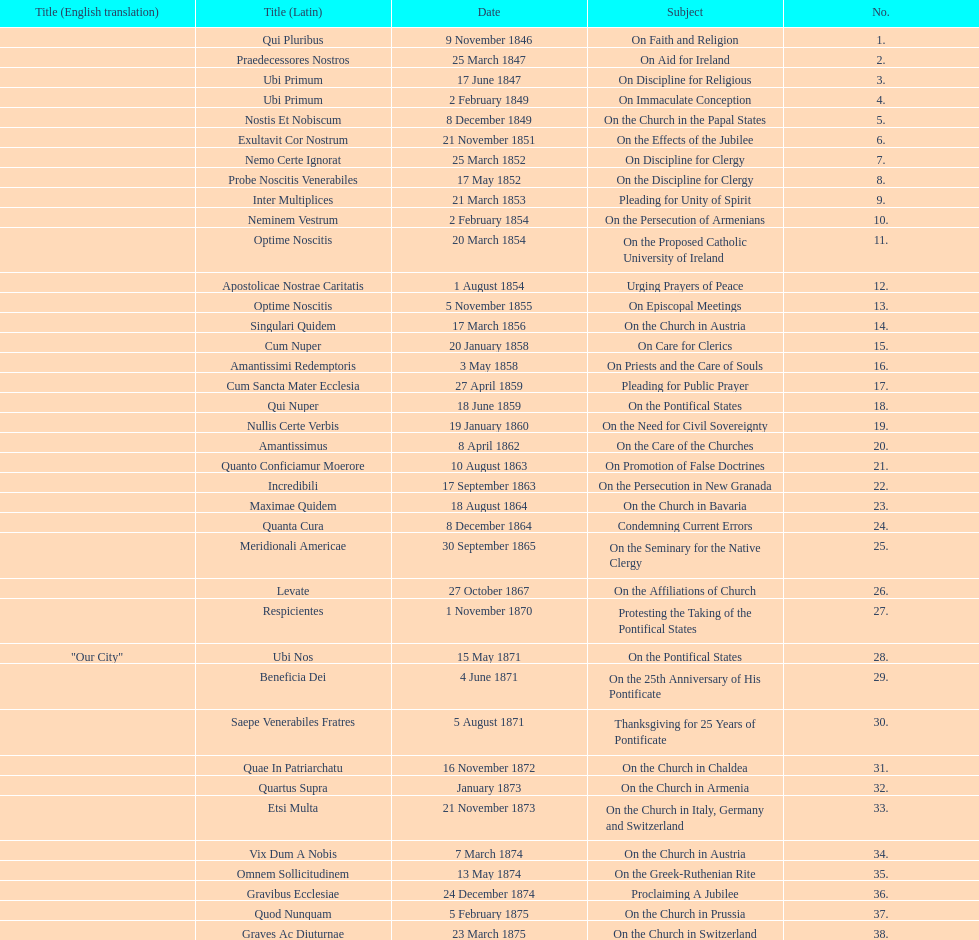In the first 10 years of his reign, how many encyclicals did pope pius ix issue? 14. 